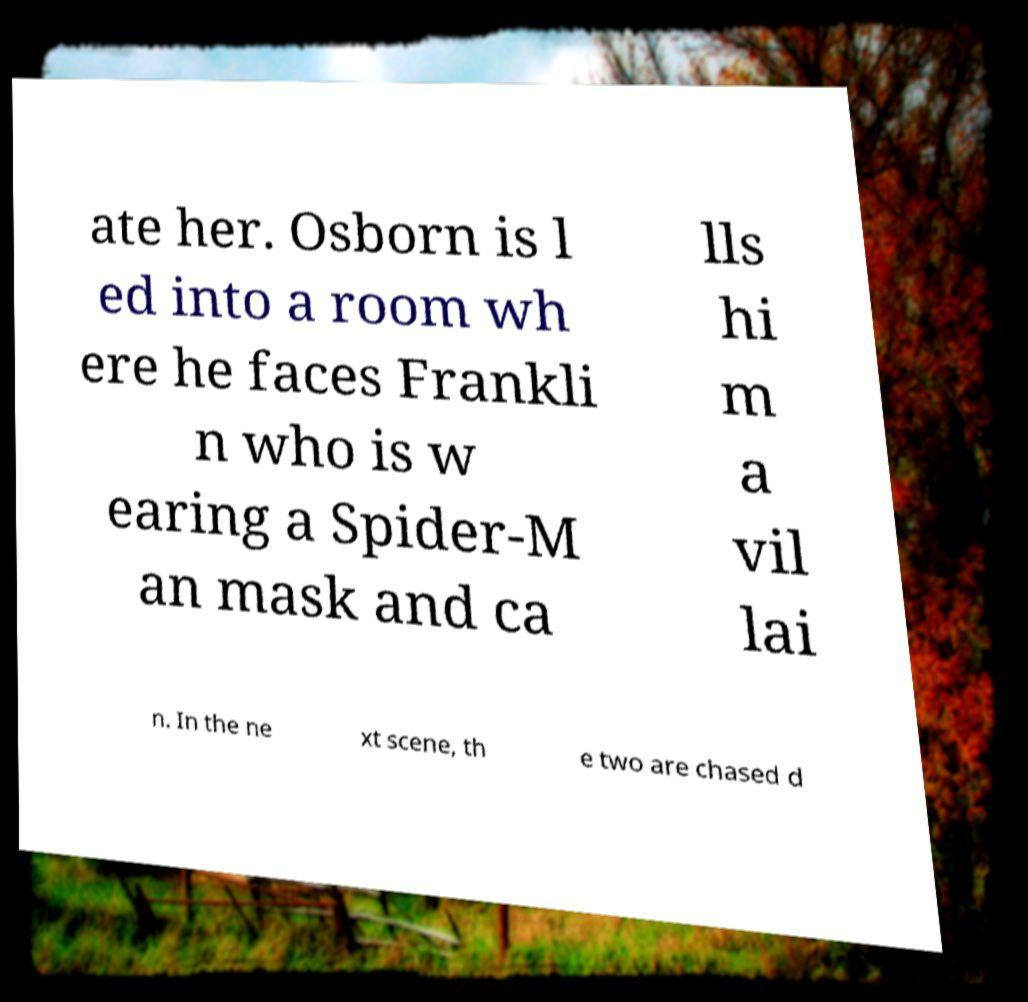Please read and relay the text visible in this image. What does it say? ate her. Osborn is l ed into a room wh ere he faces Frankli n who is w earing a Spider-M an mask and ca lls hi m a vil lai n. In the ne xt scene, th e two are chased d 